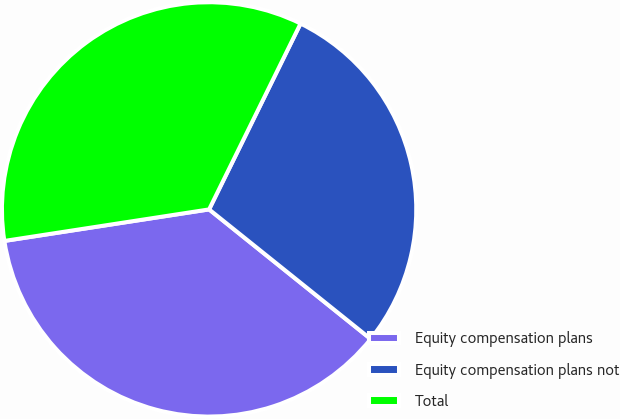Convert chart. <chart><loc_0><loc_0><loc_500><loc_500><pie_chart><fcel>Equity compensation plans<fcel>Equity compensation plans not<fcel>Total<nl><fcel>36.81%<fcel>28.48%<fcel>34.71%<nl></chart> 